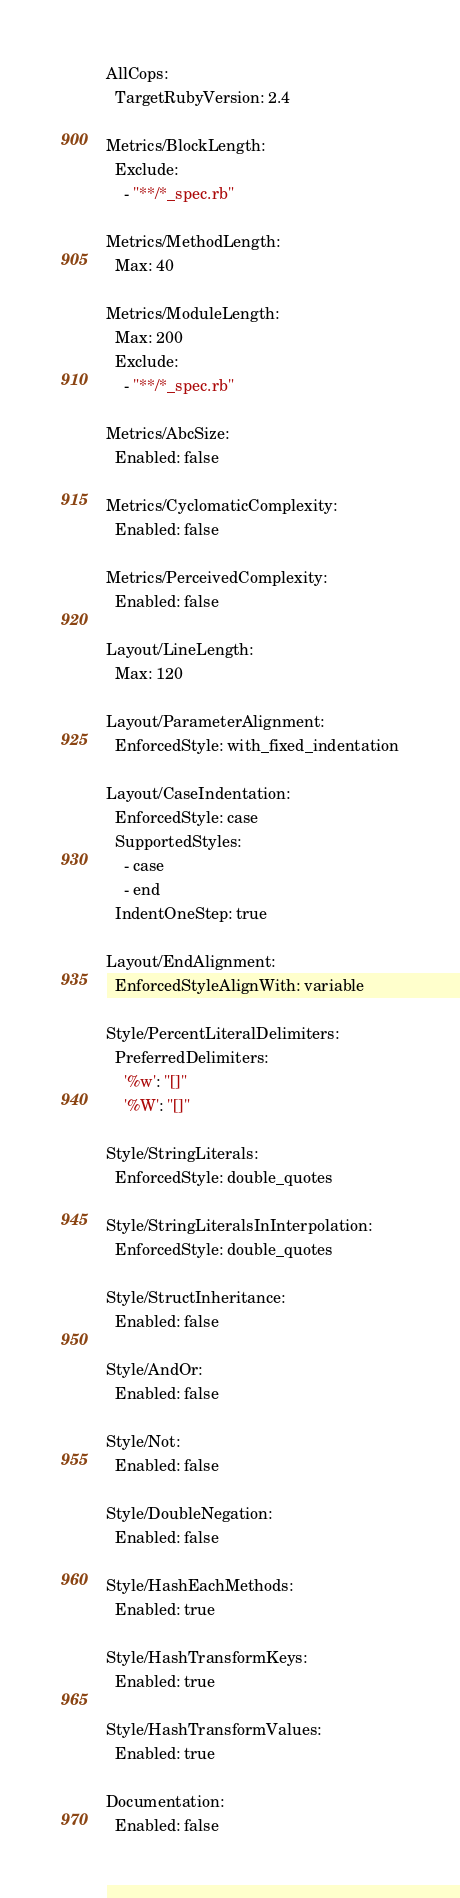<code> <loc_0><loc_0><loc_500><loc_500><_YAML_>AllCops:
  TargetRubyVersion: 2.4

Metrics/BlockLength:
  Exclude:
    - "**/*_spec.rb"

Metrics/MethodLength:
  Max: 40

Metrics/ModuleLength:
  Max: 200
  Exclude:
    - "**/*_spec.rb"

Metrics/AbcSize:
  Enabled: false

Metrics/CyclomaticComplexity:
  Enabled: false

Metrics/PerceivedComplexity:
  Enabled: false

Layout/LineLength:
  Max: 120

Layout/ParameterAlignment:
  EnforcedStyle: with_fixed_indentation

Layout/CaseIndentation:
  EnforcedStyle: case
  SupportedStyles:
    - case
    - end
  IndentOneStep: true

Layout/EndAlignment:
  EnforcedStyleAlignWith: variable

Style/PercentLiteralDelimiters:
  PreferredDelimiters:
    '%w': "[]"
    '%W': "[]"

Style/StringLiterals:
  EnforcedStyle: double_quotes

Style/StringLiteralsInInterpolation:
  EnforcedStyle: double_quotes

Style/StructInheritance:
  Enabled: false

Style/AndOr:
  Enabled: false

Style/Not:
  Enabled: false

Style/DoubleNegation:
  Enabled: false

Style/HashEachMethods:
  Enabled: true

Style/HashTransformKeys:
  Enabled: true

Style/HashTransformValues:
  Enabled: true

Documentation:
  Enabled: false</code> 